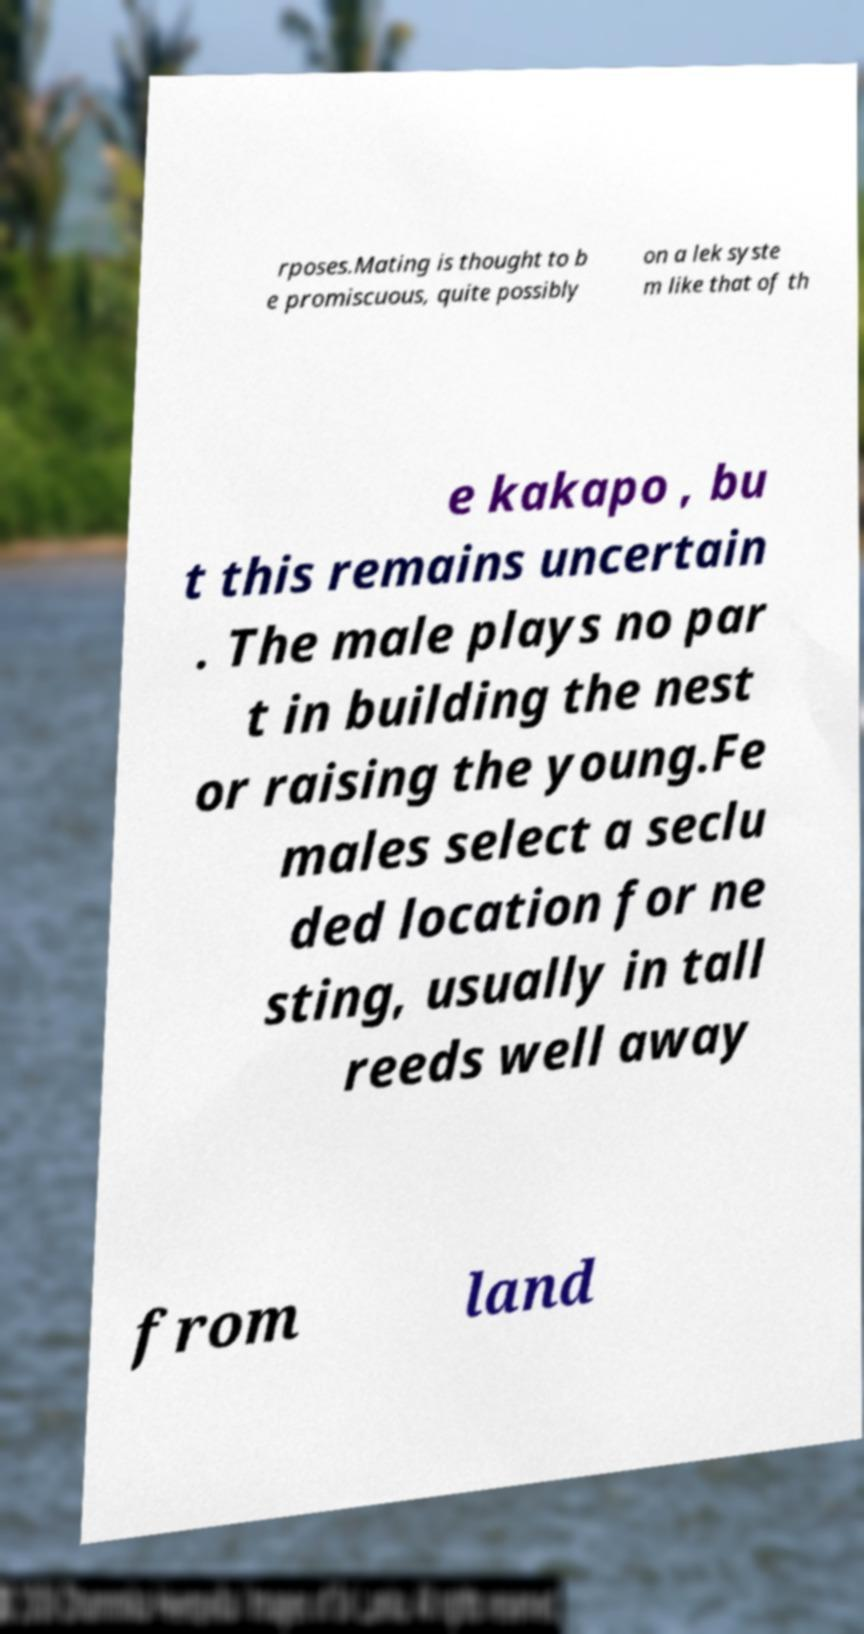Please read and relay the text visible in this image. What does it say? rposes.Mating is thought to b e promiscuous, quite possibly on a lek syste m like that of th e kakapo , bu t this remains uncertain . The male plays no par t in building the nest or raising the young.Fe males select a seclu ded location for ne sting, usually in tall reeds well away from land 